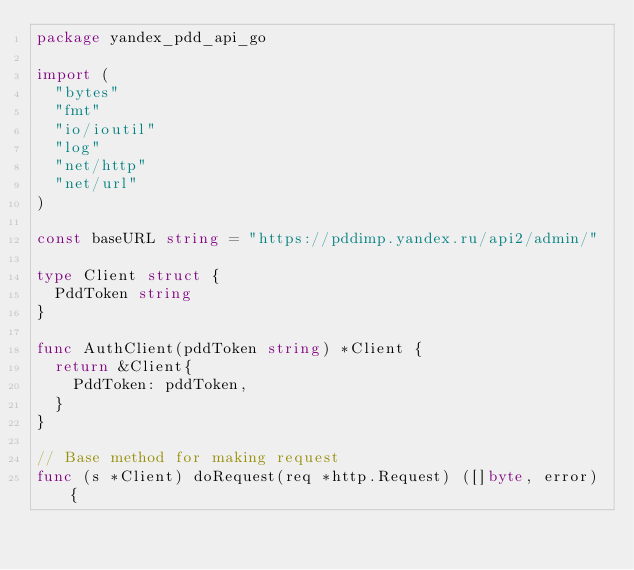<code> <loc_0><loc_0><loc_500><loc_500><_Go_>package yandex_pdd_api_go

import (
	"bytes"
	"fmt"
	"io/ioutil"
	"log"
	"net/http"
	"net/url"
)

const baseURL string = "https://pddimp.yandex.ru/api2/admin/"

type Client struct {
	PddToken string
}

func AuthClient(pddToken string) *Client {
	return &Client{
		PddToken: pddToken,
	}
}

// Base method for making request
func (s *Client) doRequest(req *http.Request) ([]byte, error) {</code> 